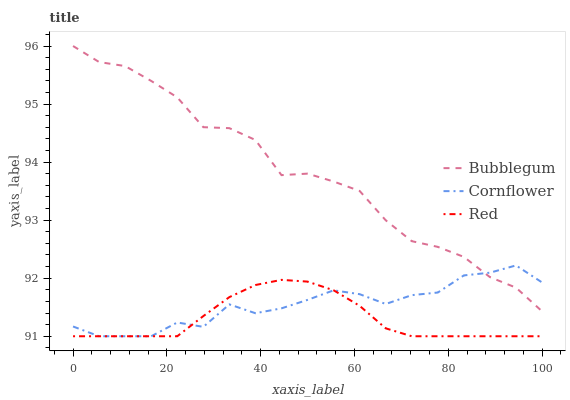Does Bubblegum have the minimum area under the curve?
Answer yes or no. No. Does Red have the maximum area under the curve?
Answer yes or no. No. Is Bubblegum the smoothest?
Answer yes or no. No. Is Red the roughest?
Answer yes or no. No. Does Bubblegum have the lowest value?
Answer yes or no. No. Does Red have the highest value?
Answer yes or no. No. Is Red less than Bubblegum?
Answer yes or no. Yes. Is Bubblegum greater than Red?
Answer yes or no. Yes. Does Red intersect Bubblegum?
Answer yes or no. No. 